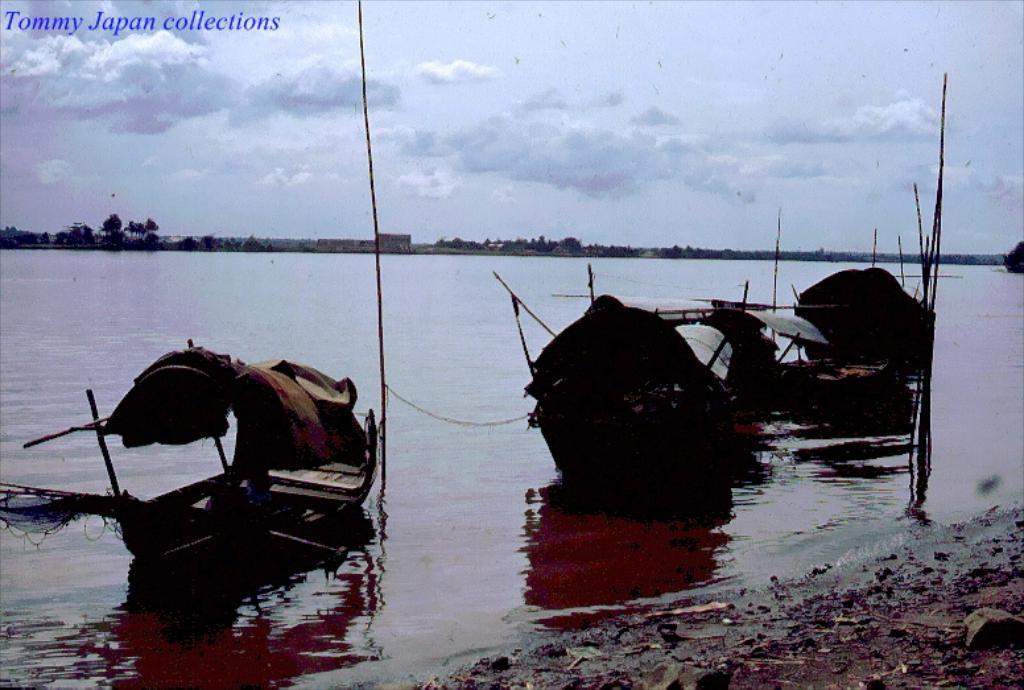How would you summarize this image in a sentence or two? In this image there are few boats in the water, there are few trees, some clouds in the sky and some text at the top of the image. 